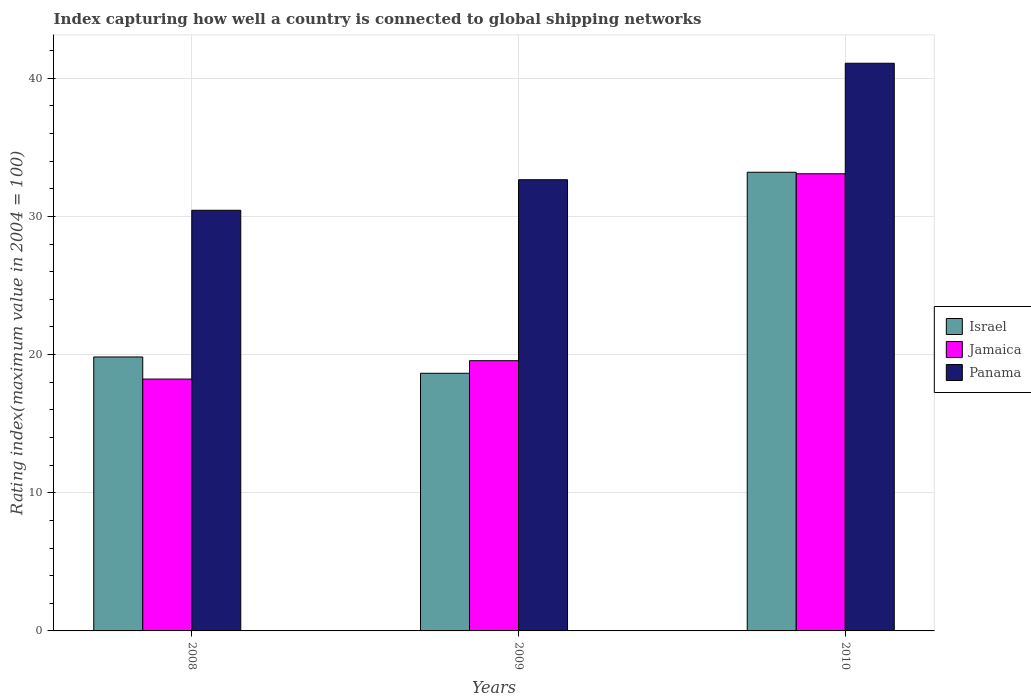How many different coloured bars are there?
Offer a very short reply. 3. How many groups of bars are there?
Your response must be concise. 3. Are the number of bars on each tick of the X-axis equal?
Your answer should be compact. Yes. What is the label of the 2nd group of bars from the left?
Your answer should be compact. 2009. In how many cases, is the number of bars for a given year not equal to the number of legend labels?
Keep it short and to the point. 0. What is the rating index in Panama in 2009?
Keep it short and to the point. 32.66. Across all years, what is the maximum rating index in Jamaica?
Provide a short and direct response. 33.09. Across all years, what is the minimum rating index in Panama?
Ensure brevity in your answer.  30.45. In which year was the rating index in Jamaica maximum?
Your response must be concise. 2010. What is the total rating index in Panama in the graph?
Keep it short and to the point. 104.2. What is the difference between the rating index in Jamaica in 2009 and that in 2010?
Ensure brevity in your answer.  -13.53. What is the difference between the rating index in Israel in 2008 and the rating index in Jamaica in 2010?
Ensure brevity in your answer.  -13.26. What is the average rating index in Jamaica per year?
Ensure brevity in your answer.  23.63. In the year 2008, what is the difference between the rating index in Israel and rating index in Jamaica?
Give a very brief answer. 1.6. In how many years, is the rating index in Jamaica greater than 40?
Keep it short and to the point. 0. What is the ratio of the rating index in Jamaica in 2008 to that in 2010?
Your response must be concise. 0.55. What is the difference between the highest and the second highest rating index in Israel?
Keep it short and to the point. 13.37. What is the difference between the highest and the lowest rating index in Israel?
Your answer should be very brief. 14.55. Is the sum of the rating index in Jamaica in 2009 and 2010 greater than the maximum rating index in Israel across all years?
Offer a terse response. Yes. What does the 3rd bar from the left in 2010 represents?
Offer a terse response. Panama. What does the 1st bar from the right in 2009 represents?
Provide a short and direct response. Panama. How many bars are there?
Your response must be concise. 9. How many years are there in the graph?
Keep it short and to the point. 3. Are the values on the major ticks of Y-axis written in scientific E-notation?
Offer a terse response. No. Does the graph contain grids?
Provide a succinct answer. Yes. How are the legend labels stacked?
Provide a short and direct response. Vertical. What is the title of the graph?
Your answer should be very brief. Index capturing how well a country is connected to global shipping networks. Does "Central Europe" appear as one of the legend labels in the graph?
Offer a very short reply. No. What is the label or title of the X-axis?
Offer a very short reply. Years. What is the label or title of the Y-axis?
Provide a succinct answer. Rating index(maximum value in 2004 = 100). What is the Rating index(maximum value in 2004 = 100) of Israel in 2008?
Your response must be concise. 19.83. What is the Rating index(maximum value in 2004 = 100) of Jamaica in 2008?
Provide a succinct answer. 18.23. What is the Rating index(maximum value in 2004 = 100) of Panama in 2008?
Give a very brief answer. 30.45. What is the Rating index(maximum value in 2004 = 100) of Israel in 2009?
Provide a succinct answer. 18.65. What is the Rating index(maximum value in 2004 = 100) of Jamaica in 2009?
Provide a short and direct response. 19.56. What is the Rating index(maximum value in 2004 = 100) in Panama in 2009?
Ensure brevity in your answer.  32.66. What is the Rating index(maximum value in 2004 = 100) in Israel in 2010?
Your answer should be very brief. 33.2. What is the Rating index(maximum value in 2004 = 100) of Jamaica in 2010?
Your response must be concise. 33.09. What is the Rating index(maximum value in 2004 = 100) in Panama in 2010?
Provide a short and direct response. 41.09. Across all years, what is the maximum Rating index(maximum value in 2004 = 100) of Israel?
Give a very brief answer. 33.2. Across all years, what is the maximum Rating index(maximum value in 2004 = 100) in Jamaica?
Make the answer very short. 33.09. Across all years, what is the maximum Rating index(maximum value in 2004 = 100) in Panama?
Make the answer very short. 41.09. Across all years, what is the minimum Rating index(maximum value in 2004 = 100) in Israel?
Keep it short and to the point. 18.65. Across all years, what is the minimum Rating index(maximum value in 2004 = 100) of Jamaica?
Give a very brief answer. 18.23. Across all years, what is the minimum Rating index(maximum value in 2004 = 100) in Panama?
Provide a succinct answer. 30.45. What is the total Rating index(maximum value in 2004 = 100) in Israel in the graph?
Ensure brevity in your answer.  71.68. What is the total Rating index(maximum value in 2004 = 100) of Jamaica in the graph?
Provide a short and direct response. 70.88. What is the total Rating index(maximum value in 2004 = 100) of Panama in the graph?
Your response must be concise. 104.2. What is the difference between the Rating index(maximum value in 2004 = 100) in Israel in 2008 and that in 2009?
Offer a very short reply. 1.18. What is the difference between the Rating index(maximum value in 2004 = 100) in Jamaica in 2008 and that in 2009?
Offer a very short reply. -1.33. What is the difference between the Rating index(maximum value in 2004 = 100) of Panama in 2008 and that in 2009?
Your answer should be very brief. -2.21. What is the difference between the Rating index(maximum value in 2004 = 100) of Israel in 2008 and that in 2010?
Provide a succinct answer. -13.37. What is the difference between the Rating index(maximum value in 2004 = 100) of Jamaica in 2008 and that in 2010?
Make the answer very short. -14.86. What is the difference between the Rating index(maximum value in 2004 = 100) of Panama in 2008 and that in 2010?
Keep it short and to the point. -10.64. What is the difference between the Rating index(maximum value in 2004 = 100) in Israel in 2009 and that in 2010?
Ensure brevity in your answer.  -14.55. What is the difference between the Rating index(maximum value in 2004 = 100) of Jamaica in 2009 and that in 2010?
Give a very brief answer. -13.53. What is the difference between the Rating index(maximum value in 2004 = 100) of Panama in 2009 and that in 2010?
Ensure brevity in your answer.  -8.43. What is the difference between the Rating index(maximum value in 2004 = 100) in Israel in 2008 and the Rating index(maximum value in 2004 = 100) in Jamaica in 2009?
Your answer should be compact. 0.27. What is the difference between the Rating index(maximum value in 2004 = 100) of Israel in 2008 and the Rating index(maximum value in 2004 = 100) of Panama in 2009?
Keep it short and to the point. -12.83. What is the difference between the Rating index(maximum value in 2004 = 100) in Jamaica in 2008 and the Rating index(maximum value in 2004 = 100) in Panama in 2009?
Keep it short and to the point. -14.43. What is the difference between the Rating index(maximum value in 2004 = 100) of Israel in 2008 and the Rating index(maximum value in 2004 = 100) of Jamaica in 2010?
Provide a short and direct response. -13.26. What is the difference between the Rating index(maximum value in 2004 = 100) of Israel in 2008 and the Rating index(maximum value in 2004 = 100) of Panama in 2010?
Your response must be concise. -21.26. What is the difference between the Rating index(maximum value in 2004 = 100) of Jamaica in 2008 and the Rating index(maximum value in 2004 = 100) of Panama in 2010?
Keep it short and to the point. -22.86. What is the difference between the Rating index(maximum value in 2004 = 100) in Israel in 2009 and the Rating index(maximum value in 2004 = 100) in Jamaica in 2010?
Offer a very short reply. -14.44. What is the difference between the Rating index(maximum value in 2004 = 100) of Israel in 2009 and the Rating index(maximum value in 2004 = 100) of Panama in 2010?
Give a very brief answer. -22.44. What is the difference between the Rating index(maximum value in 2004 = 100) of Jamaica in 2009 and the Rating index(maximum value in 2004 = 100) of Panama in 2010?
Provide a short and direct response. -21.53. What is the average Rating index(maximum value in 2004 = 100) of Israel per year?
Give a very brief answer. 23.89. What is the average Rating index(maximum value in 2004 = 100) in Jamaica per year?
Your answer should be compact. 23.63. What is the average Rating index(maximum value in 2004 = 100) of Panama per year?
Make the answer very short. 34.73. In the year 2008, what is the difference between the Rating index(maximum value in 2004 = 100) of Israel and Rating index(maximum value in 2004 = 100) of Jamaica?
Provide a succinct answer. 1.6. In the year 2008, what is the difference between the Rating index(maximum value in 2004 = 100) of Israel and Rating index(maximum value in 2004 = 100) of Panama?
Your answer should be very brief. -10.62. In the year 2008, what is the difference between the Rating index(maximum value in 2004 = 100) in Jamaica and Rating index(maximum value in 2004 = 100) in Panama?
Provide a succinct answer. -12.22. In the year 2009, what is the difference between the Rating index(maximum value in 2004 = 100) of Israel and Rating index(maximum value in 2004 = 100) of Jamaica?
Give a very brief answer. -0.91. In the year 2009, what is the difference between the Rating index(maximum value in 2004 = 100) of Israel and Rating index(maximum value in 2004 = 100) of Panama?
Provide a succinct answer. -14.01. In the year 2009, what is the difference between the Rating index(maximum value in 2004 = 100) in Jamaica and Rating index(maximum value in 2004 = 100) in Panama?
Make the answer very short. -13.1. In the year 2010, what is the difference between the Rating index(maximum value in 2004 = 100) in Israel and Rating index(maximum value in 2004 = 100) in Jamaica?
Ensure brevity in your answer.  0.11. In the year 2010, what is the difference between the Rating index(maximum value in 2004 = 100) of Israel and Rating index(maximum value in 2004 = 100) of Panama?
Keep it short and to the point. -7.89. In the year 2010, what is the difference between the Rating index(maximum value in 2004 = 100) of Jamaica and Rating index(maximum value in 2004 = 100) of Panama?
Your answer should be very brief. -8. What is the ratio of the Rating index(maximum value in 2004 = 100) of Israel in 2008 to that in 2009?
Your response must be concise. 1.06. What is the ratio of the Rating index(maximum value in 2004 = 100) of Jamaica in 2008 to that in 2009?
Provide a succinct answer. 0.93. What is the ratio of the Rating index(maximum value in 2004 = 100) of Panama in 2008 to that in 2009?
Your answer should be very brief. 0.93. What is the ratio of the Rating index(maximum value in 2004 = 100) of Israel in 2008 to that in 2010?
Make the answer very short. 0.6. What is the ratio of the Rating index(maximum value in 2004 = 100) of Jamaica in 2008 to that in 2010?
Ensure brevity in your answer.  0.55. What is the ratio of the Rating index(maximum value in 2004 = 100) in Panama in 2008 to that in 2010?
Provide a succinct answer. 0.74. What is the ratio of the Rating index(maximum value in 2004 = 100) of Israel in 2009 to that in 2010?
Provide a short and direct response. 0.56. What is the ratio of the Rating index(maximum value in 2004 = 100) in Jamaica in 2009 to that in 2010?
Your response must be concise. 0.59. What is the ratio of the Rating index(maximum value in 2004 = 100) in Panama in 2009 to that in 2010?
Make the answer very short. 0.79. What is the difference between the highest and the second highest Rating index(maximum value in 2004 = 100) in Israel?
Ensure brevity in your answer.  13.37. What is the difference between the highest and the second highest Rating index(maximum value in 2004 = 100) in Jamaica?
Your answer should be very brief. 13.53. What is the difference between the highest and the second highest Rating index(maximum value in 2004 = 100) of Panama?
Make the answer very short. 8.43. What is the difference between the highest and the lowest Rating index(maximum value in 2004 = 100) of Israel?
Ensure brevity in your answer.  14.55. What is the difference between the highest and the lowest Rating index(maximum value in 2004 = 100) in Jamaica?
Give a very brief answer. 14.86. What is the difference between the highest and the lowest Rating index(maximum value in 2004 = 100) in Panama?
Offer a terse response. 10.64. 